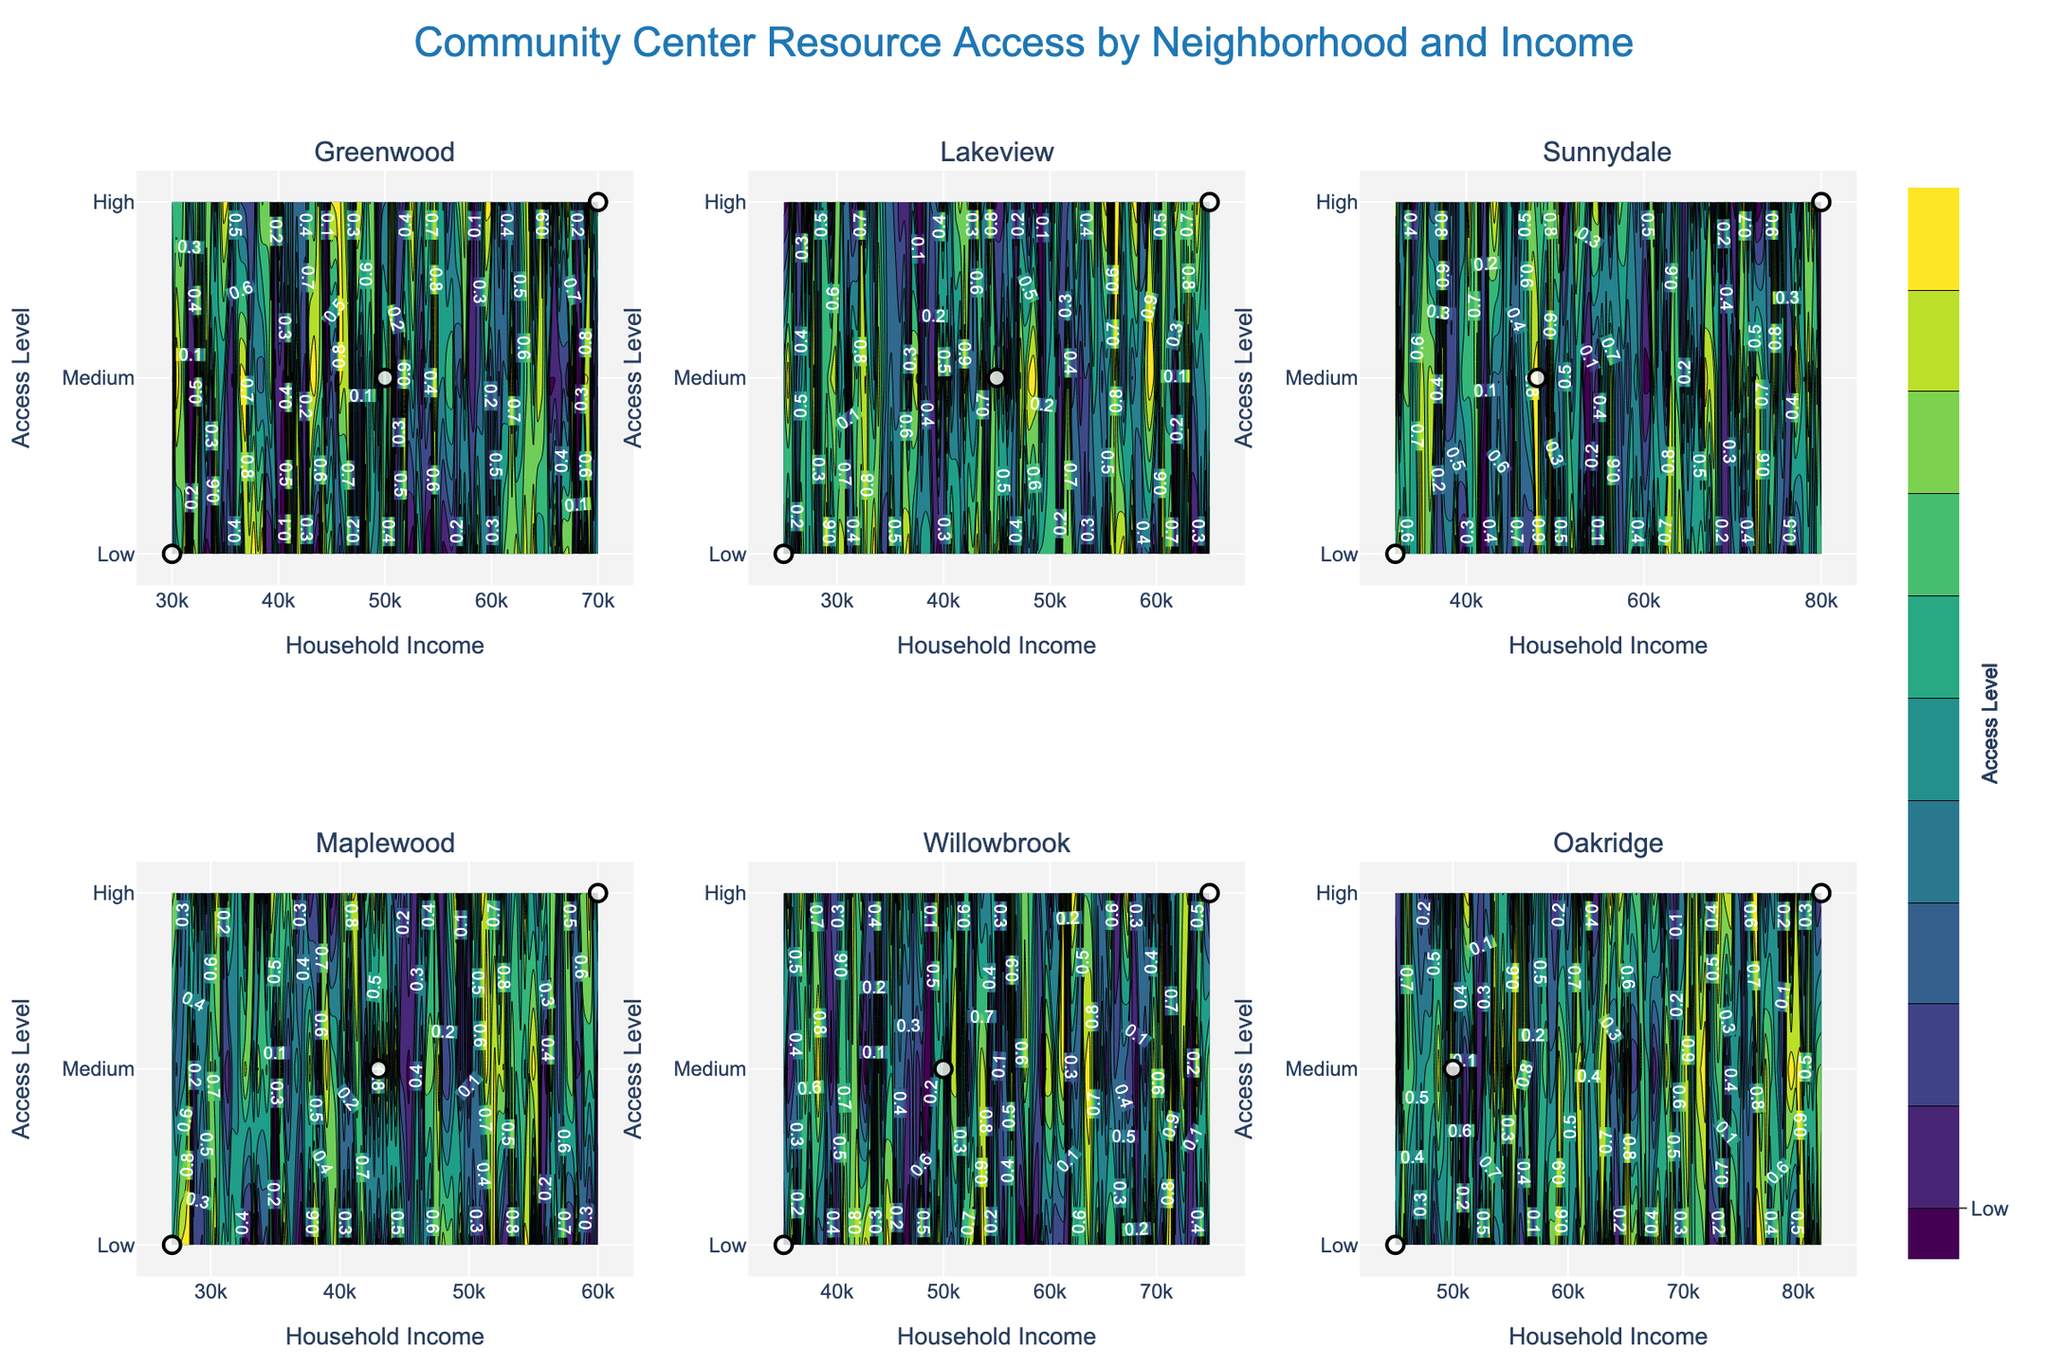What is the title of the figure? The title is usually located at the top of the figure. In this case, it reads: "Community Center Resource Access by Neighborhood and Income"
Answer: Community Center Resource Access by Neighborhood and Income How many neighborhoods are included in the figure? The subplot titles, which appear above each contour plot, indicate the neighborhoods. By counting these titles, we identify six neighborhoods: Greenwood, Lakeview, Sunnydale, Maplewood, Willowbrook, and Oakridge
Answer: Six Which neighborhood shows 'High' access to community center resources at the lowest income level? By comparing all subplots, we see that Lakeview has 'High' access at a household income of $25,000, which is the lowest among all neighborhoods
Answer: Lakeview In which neighborhood does 'High' access to community center resources correspond to the highest income level? Examining each subplot for the usage of the 'High' access level against the x-axis, we see that Willowbrook, with an income level of $35,000, has the highest income among those categorized with 'High' access
Answer: Willowbrook Does Oakridge show any 'High' access to community center resources? Looking at the Oakridge subplot, we can observe that there are no data points nor contours indicating 'High' access among any income levels
Answer: No Which neighborhoods have medium access to community center resources for household incomes around $50,000? In the respective subplots for each neighborhood, we observe that Greenwood, Willowbrook, and Oakridge each demonstrate 'Medium' access levels around the $50,000 income level
Answer: Greenwood, Willowbrook, Oakridge Comparing Greenwood and Sunnydale, which neighborhood has more variation in access levels across household incomes? By examining the range of access levels in each neighborhood's subplot, we see that Greenwood has 'High', 'Medium', and 'Low' access levels, whereas Sunnydale only shows 'Medium', 'High', and 'Low' access across incomes. Greenwood’s variation is greater
Answer: Greenwood Which neighborhood has the largest income range covered in the subplot? Observing the x-axes of each subplot, we determine that Sunnydale shows household incomes ranging from $32,000 to $80,000, which is the largest range among all neighborhoods
Answer: Sunnydale 